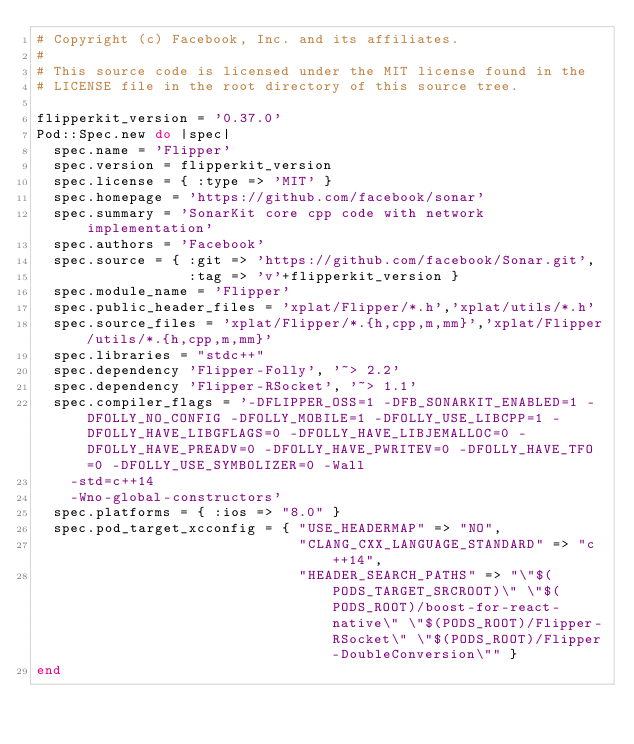<code> <loc_0><loc_0><loc_500><loc_500><_Ruby_># Copyright (c) Facebook, Inc. and its affiliates.
#
# This source code is licensed under the MIT license found in the
# LICENSE file in the root directory of this source tree.

flipperkit_version = '0.37.0'
Pod::Spec.new do |spec|
  spec.name = 'Flipper'
  spec.version = flipperkit_version
  spec.license = { :type => 'MIT' }
  spec.homepage = 'https://github.com/facebook/sonar'
  spec.summary = 'SonarKit core cpp code with network implementation'
  spec.authors = 'Facebook'
  spec.source = { :git => 'https://github.com/facebook/Sonar.git',
                  :tag => 'v'+flipperkit_version }
  spec.module_name = 'Flipper'
  spec.public_header_files = 'xplat/Flipper/*.h','xplat/utils/*.h'
  spec.source_files = 'xplat/Flipper/*.{h,cpp,m,mm}','xplat/Flipper/utils/*.{h,cpp,m,mm}'
  spec.libraries = "stdc++"
  spec.dependency 'Flipper-Folly', '~> 2.2'
  spec.dependency 'Flipper-RSocket', '~> 1.1'
  spec.compiler_flags = '-DFLIPPER_OSS=1 -DFB_SONARKIT_ENABLED=1 -DFOLLY_NO_CONFIG -DFOLLY_MOBILE=1 -DFOLLY_USE_LIBCPP=1 -DFOLLY_HAVE_LIBGFLAGS=0 -DFOLLY_HAVE_LIBJEMALLOC=0 -DFOLLY_HAVE_PREADV=0 -DFOLLY_HAVE_PWRITEV=0 -DFOLLY_HAVE_TFO=0 -DFOLLY_USE_SYMBOLIZER=0 -Wall
    -std=c++14
    -Wno-global-constructors'
  spec.platforms = { :ios => "8.0" }
  spec.pod_target_xcconfig = { "USE_HEADERMAP" => "NO",
                               "CLANG_CXX_LANGUAGE_STANDARD" => "c++14",
                               "HEADER_SEARCH_PATHS" => "\"$(PODS_TARGET_SRCROOT)\" \"$(PODS_ROOT)/boost-for-react-native\" \"$(PODS_ROOT)/Flipper-RSocket\" \"$(PODS_ROOT)/Flipper-DoubleConversion\"" }
end
</code> 